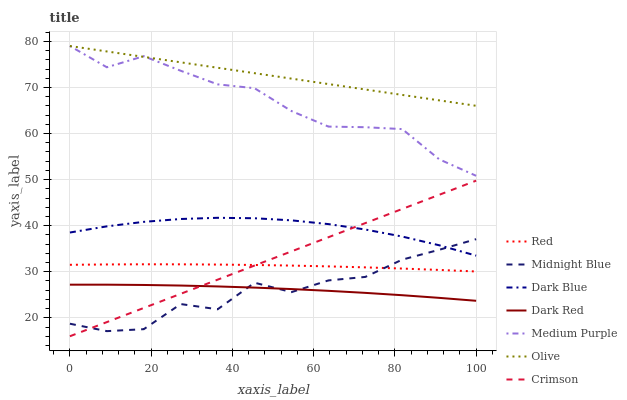Does Midnight Blue have the minimum area under the curve?
Answer yes or no. Yes. Does Olive have the maximum area under the curve?
Answer yes or no. Yes. Does Dark Red have the minimum area under the curve?
Answer yes or no. No. Does Dark Red have the maximum area under the curve?
Answer yes or no. No. Is Crimson the smoothest?
Answer yes or no. Yes. Is Midnight Blue the roughest?
Answer yes or no. Yes. Is Dark Red the smoothest?
Answer yes or no. No. Is Dark Red the roughest?
Answer yes or no. No. Does Crimson have the lowest value?
Answer yes or no. Yes. Does Dark Red have the lowest value?
Answer yes or no. No. Does Olive have the highest value?
Answer yes or no. Yes. Does Dark Red have the highest value?
Answer yes or no. No. Is Midnight Blue less than Olive?
Answer yes or no. Yes. Is Dark Blue greater than Dark Red?
Answer yes or no. Yes. Does Red intersect Midnight Blue?
Answer yes or no. Yes. Is Red less than Midnight Blue?
Answer yes or no. No. Is Red greater than Midnight Blue?
Answer yes or no. No. Does Midnight Blue intersect Olive?
Answer yes or no. No. 